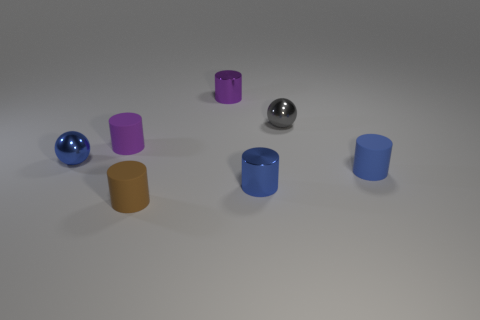Do the metal cylinder that is behind the tiny blue ball and the blue metal cylinder on the right side of the purple matte object have the same size?
Offer a terse response. Yes. There is a blue matte cylinder; is its size the same as the metal sphere behind the blue shiny sphere?
Offer a very short reply. Yes. What is the size of the blue metal object in front of the blue object that is to the left of the small brown cylinder?
Provide a succinct answer. Small. There is another tiny object that is the same shape as the small gray shiny thing; what is its color?
Offer a very short reply. Blue. Is the size of the brown matte object the same as the gray shiny sphere?
Your answer should be very brief. Yes. Is the number of small purple things that are right of the gray object the same as the number of brown cylinders?
Keep it short and to the point. No. There is a tiny blue cylinder that is left of the tiny gray metallic ball; are there any cylinders that are in front of it?
Keep it short and to the point. Yes. There is a sphere that is to the left of the small sphere that is to the right of the purple metal object; what is it made of?
Provide a short and direct response. Metal. Are there any other metal things of the same shape as the small gray metallic thing?
Keep it short and to the point. Yes. What is the shape of the tiny blue matte thing?
Offer a terse response. Cylinder. 